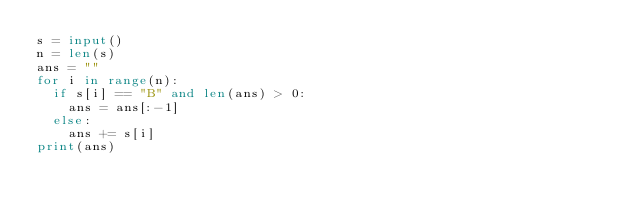<code> <loc_0><loc_0><loc_500><loc_500><_Python_>s = input()
n = len(s)
ans = ""
for i in range(n):
  if s[i] == "B" and len(ans) > 0:
    ans = ans[:-1]
  else:
    ans += s[i]
print(ans)</code> 